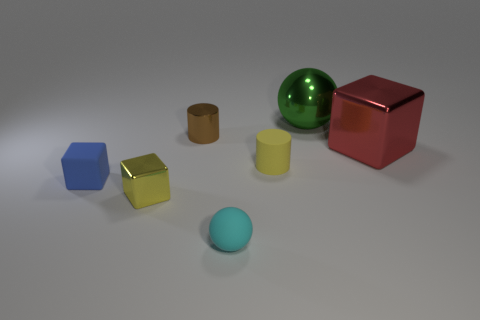Add 3 small cyan rubber cylinders. How many objects exist? 10 Subtract all blocks. How many objects are left? 4 Add 5 tiny matte cylinders. How many tiny matte cylinders are left? 6 Add 6 tiny gray matte balls. How many tiny gray matte balls exist? 6 Subtract 1 red cubes. How many objects are left? 6 Subtract all cyan shiny blocks. Subtract all small matte balls. How many objects are left? 6 